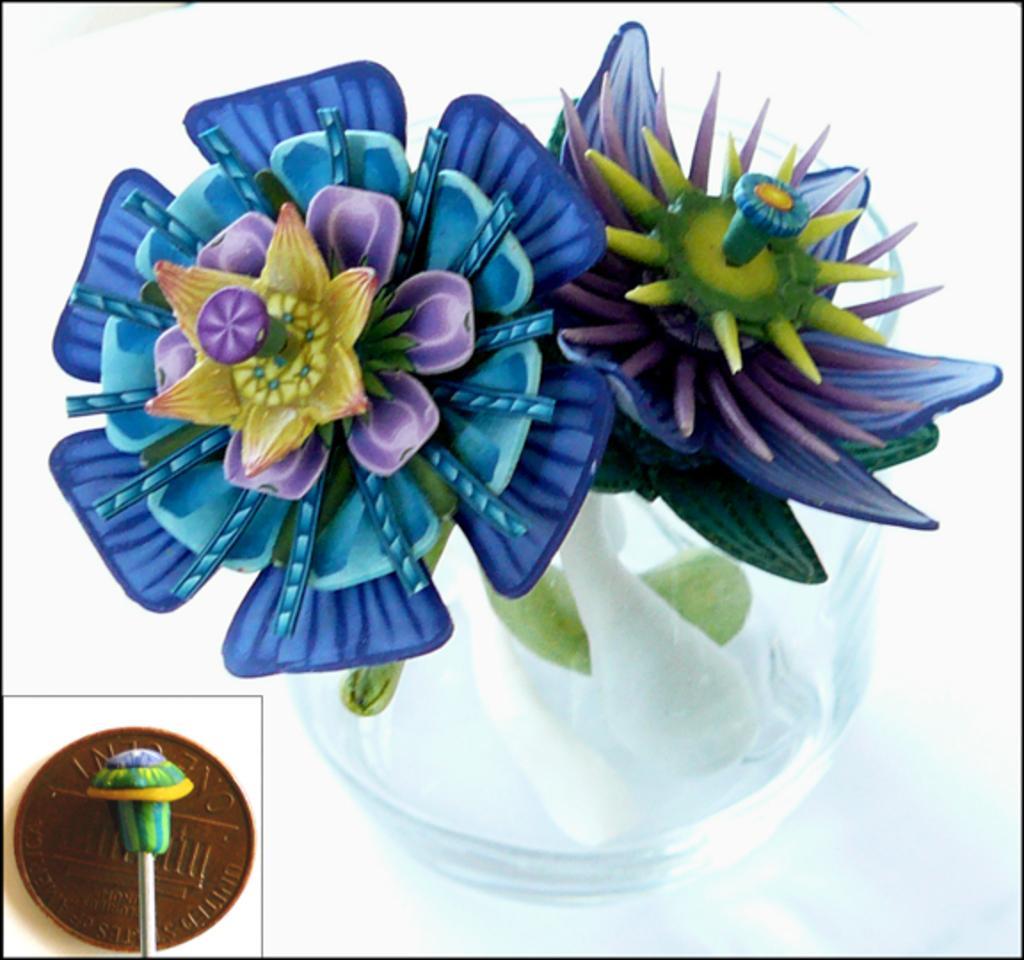Describe this image in one or two sentences. In this image there is an artificial flower in the pot and there are objects. 